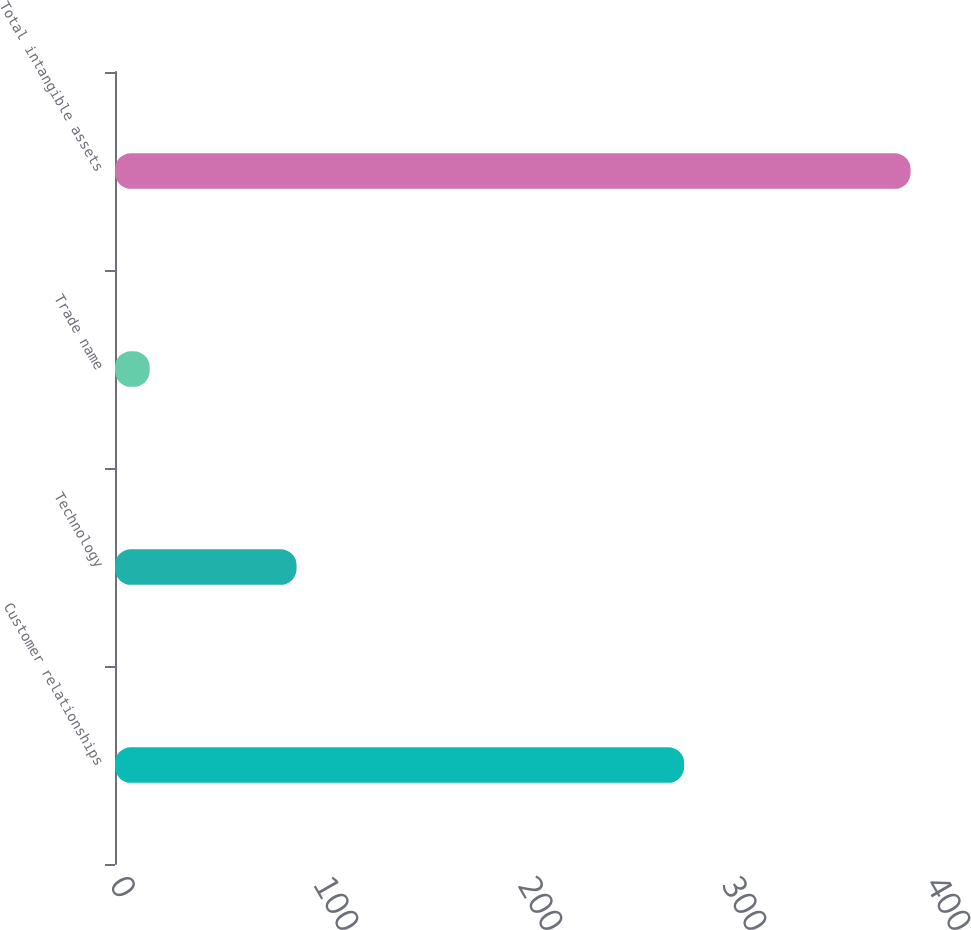Convert chart to OTSL. <chart><loc_0><loc_0><loc_500><loc_500><bar_chart><fcel>Customer relationships<fcel>Technology<fcel>Trade name<fcel>Total intangible assets<nl><fcel>279<fcel>89<fcel>17<fcel>390<nl></chart> 